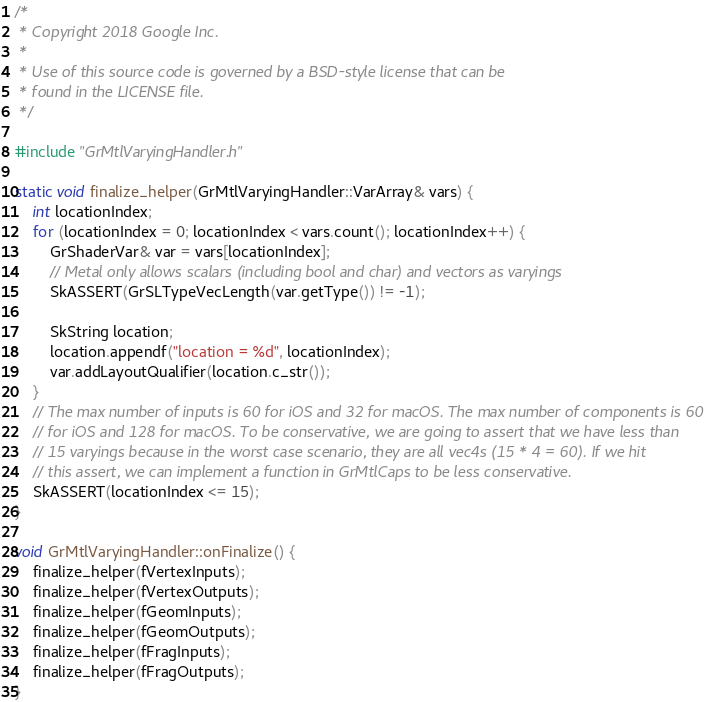Convert code to text. <code><loc_0><loc_0><loc_500><loc_500><_ObjectiveC_>/*
 * Copyright 2018 Google Inc.
 *
 * Use of this source code is governed by a BSD-style license that can be
 * found in the LICENSE file.
 */

#include "GrMtlVaryingHandler.h"

static void finalize_helper(GrMtlVaryingHandler::VarArray& vars) {
    int locationIndex;
    for (locationIndex = 0; locationIndex < vars.count(); locationIndex++) {
        GrShaderVar& var = vars[locationIndex];
        // Metal only allows scalars (including bool and char) and vectors as varyings
        SkASSERT(GrSLTypeVecLength(var.getType()) != -1);

        SkString location;
        location.appendf("location = %d", locationIndex);
        var.addLayoutQualifier(location.c_str());
    }
    // The max number of inputs is 60 for iOS and 32 for macOS. The max number of components is 60
    // for iOS and 128 for macOS. To be conservative, we are going to assert that we have less than
    // 15 varyings because in the worst case scenario, they are all vec4s (15 * 4 = 60). If we hit
    // this assert, we can implement a function in GrMtlCaps to be less conservative.
    SkASSERT(locationIndex <= 15);
}

void GrMtlVaryingHandler::onFinalize() {
    finalize_helper(fVertexInputs);
    finalize_helper(fVertexOutputs);
    finalize_helper(fGeomInputs);
    finalize_helper(fGeomOutputs);
    finalize_helper(fFragInputs);
    finalize_helper(fFragOutputs);
}
</code> 